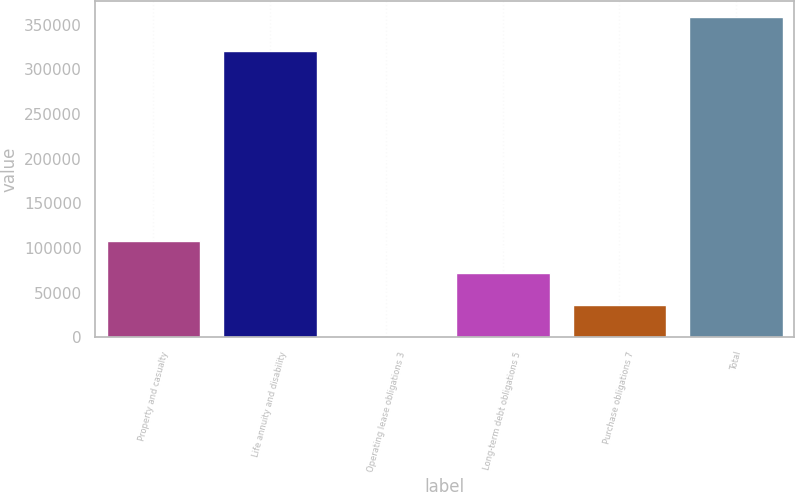<chart> <loc_0><loc_0><loc_500><loc_500><bar_chart><fcel>Property and casualty<fcel>Life annuity and disability<fcel>Operating lease obligations 3<fcel>Long-term debt obligations 5<fcel>Purchase obligations 7<fcel>Total<nl><fcel>107696<fcel>320661<fcel>231<fcel>71874.4<fcel>36052.7<fcel>358448<nl></chart> 